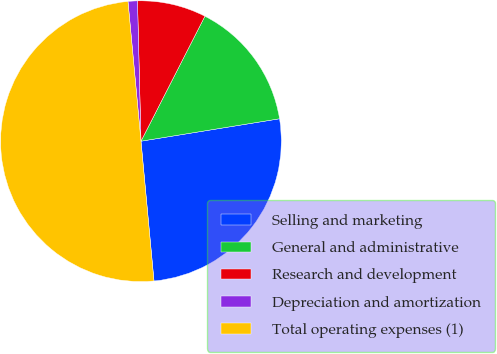<chart> <loc_0><loc_0><loc_500><loc_500><pie_chart><fcel>Selling and marketing<fcel>General and administrative<fcel>Research and development<fcel>Depreciation and amortization<fcel>Total operating expenses (1)<nl><fcel>26.08%<fcel>14.92%<fcel>7.92%<fcel>1.08%<fcel>50.0%<nl></chart> 